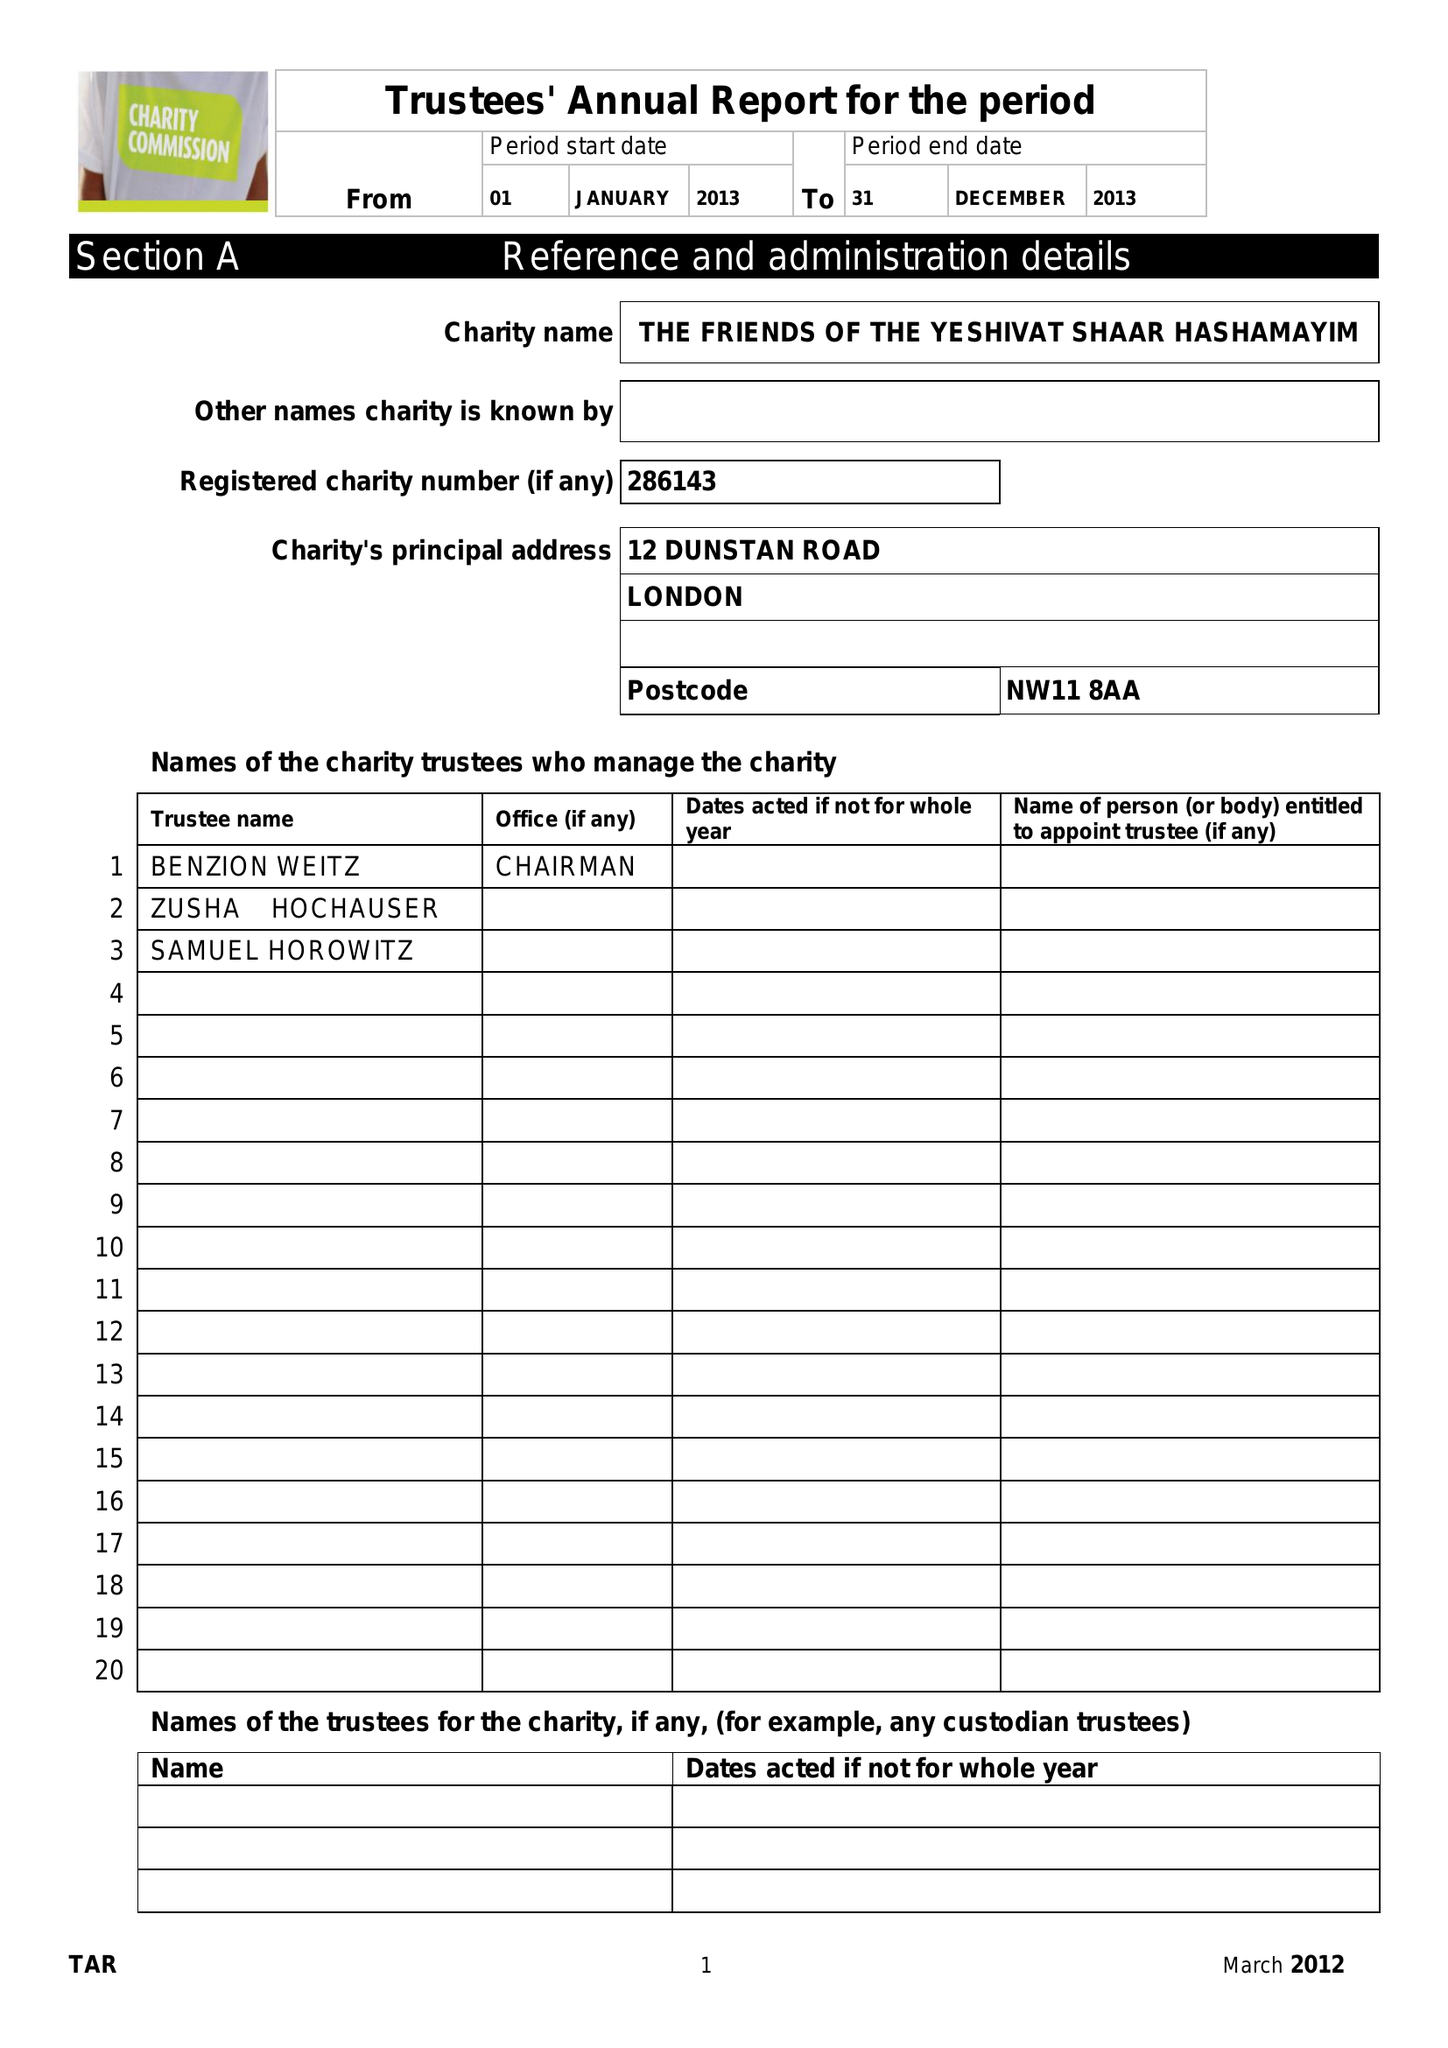What is the value for the spending_annually_in_british_pounds?
Answer the question using a single word or phrase. 73015.00 